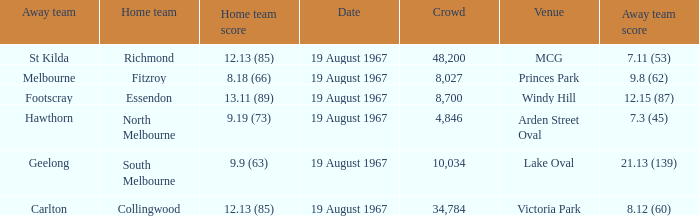When the away team scored 7.11 (53) what venue did they play at? MCG. 